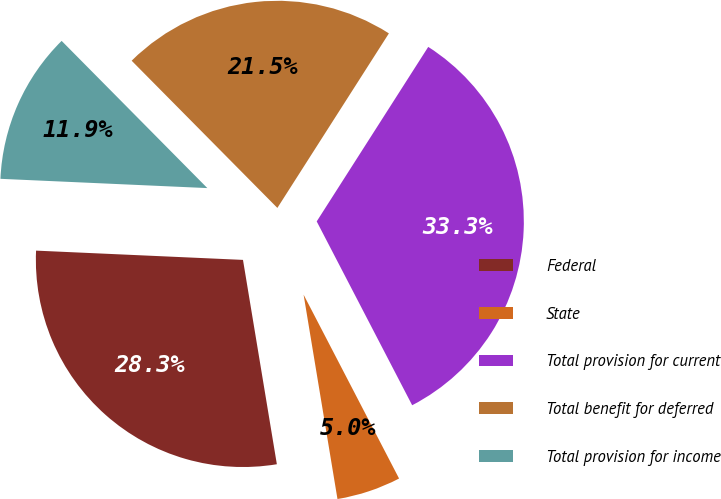Convert chart. <chart><loc_0><loc_0><loc_500><loc_500><pie_chart><fcel>Federal<fcel>State<fcel>Total provision for current<fcel>Total benefit for deferred<fcel>Total provision for income<nl><fcel>28.33%<fcel>5.01%<fcel>33.33%<fcel>21.47%<fcel>11.87%<nl></chart> 